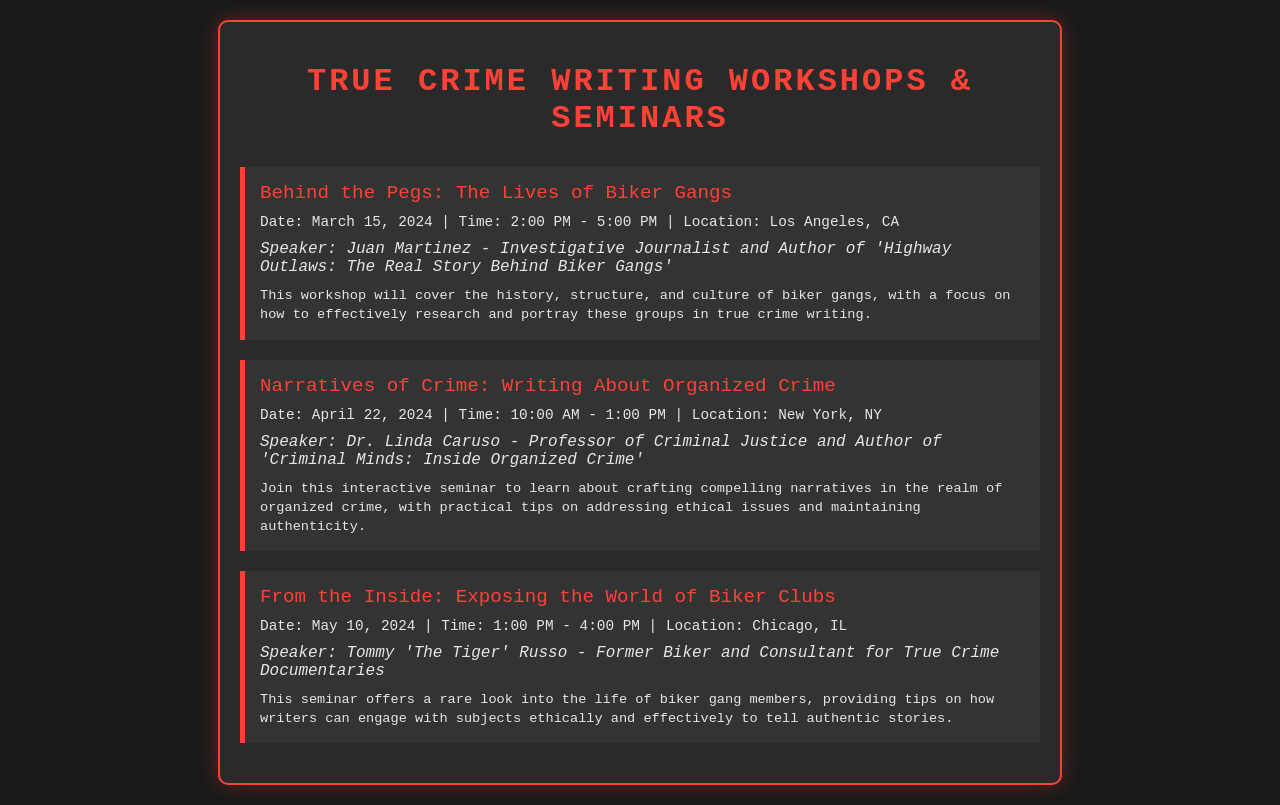What is the title of the first workshop? The title of the first workshop is provided in the event section of the document.
Answer: Behind the Pegs: The Lives of Biker Gangs When is the seminar on writing about organized crime scheduled? The date can be found in the event details of the seminar section.
Answer: April 22, 2024 Who is the speaker for the seminar on exposing the world of biker clubs? The speaker's name is listed in the event section under the second seminar.
Answer: Tommy 'The Tiger' Russo How long is the workshop on biker gangs? The duration is indicated in the event details for the respective workshop.
Answer: 3 hours What city will the workshop about biker gangs be held in? The location of the workshop is found in the event details.
Answer: Los Angeles, CA What is the focus of the seminar led by Dr. Linda Caruso? The focus is described in the seminar's description section.
Answer: Crafting compelling narratives in the realm of organized crime How many workshops or seminars are listed in the document? The number of events can be counted from the document's event sections.
Answer: 3 What is the time for the workshop in Chicago? The time is found in the event details for the workshop in Chicago.
Answer: 1:00 PM - 4:00 PM 